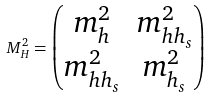<formula> <loc_0><loc_0><loc_500><loc_500>M _ { H } ^ { 2 } = \begin{pmatrix} m _ { h } ^ { 2 } & m _ { h h _ { s } } ^ { 2 } \\ m _ { h h _ { s } } ^ { 2 } & m _ { h _ { s } } ^ { 2 } \end{pmatrix}</formula> 